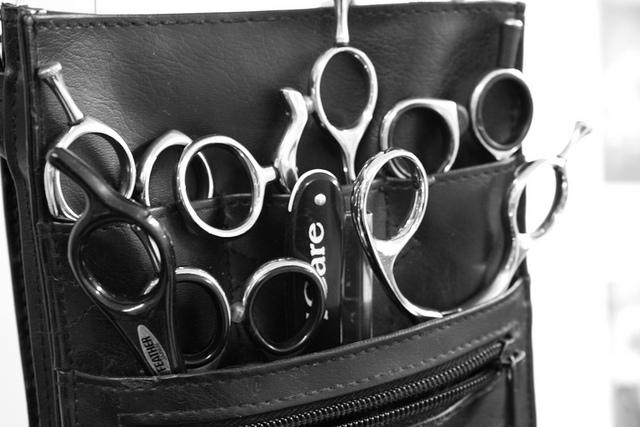What animal might the black item have come from? cow 